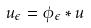Convert formula to latex. <formula><loc_0><loc_0><loc_500><loc_500>u _ { \epsilon } = \phi _ { \epsilon } * u</formula> 